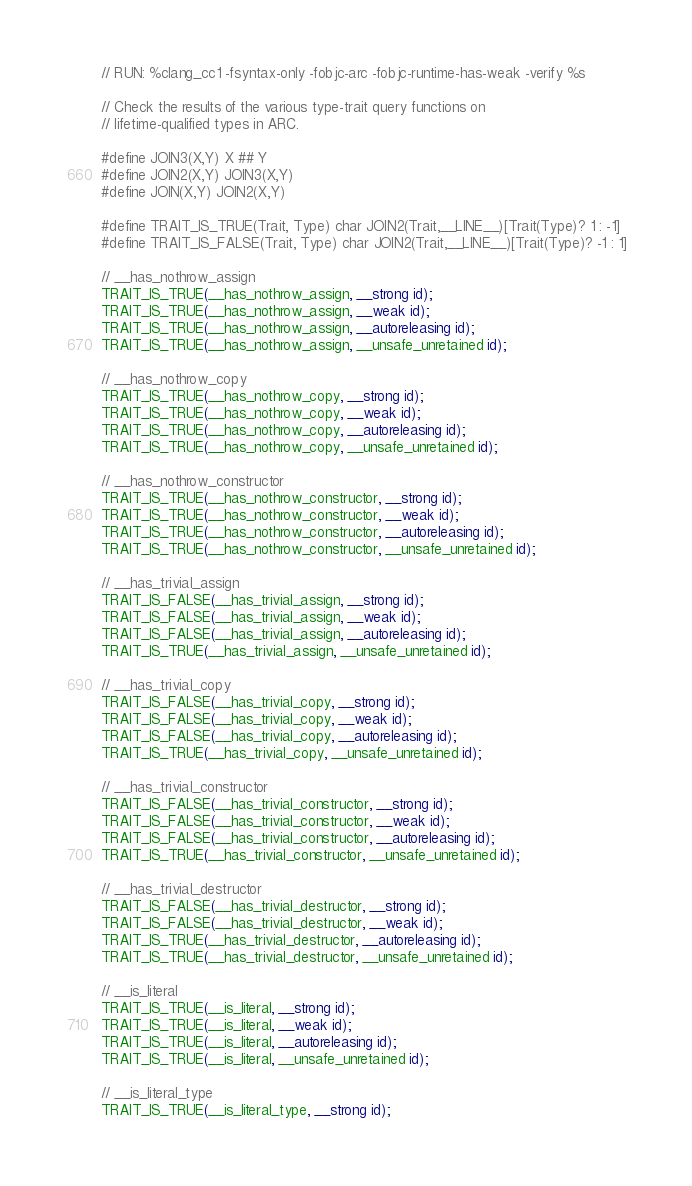<code> <loc_0><loc_0><loc_500><loc_500><_ObjectiveC_>// RUN: %clang_cc1 -fsyntax-only -fobjc-arc -fobjc-runtime-has-weak -verify %s

// Check the results of the various type-trait query functions on
// lifetime-qualified types in ARC.

#define JOIN3(X,Y) X ## Y
#define JOIN2(X,Y) JOIN3(X,Y)
#define JOIN(X,Y) JOIN2(X,Y)

#define TRAIT_IS_TRUE(Trait, Type) char JOIN2(Trait,__LINE__)[Trait(Type)? 1 : -1]
#define TRAIT_IS_FALSE(Trait, Type) char JOIN2(Trait,__LINE__)[Trait(Type)? -1 : 1]
  
// __has_nothrow_assign
TRAIT_IS_TRUE(__has_nothrow_assign, __strong id);
TRAIT_IS_TRUE(__has_nothrow_assign, __weak id);
TRAIT_IS_TRUE(__has_nothrow_assign, __autoreleasing id);
TRAIT_IS_TRUE(__has_nothrow_assign, __unsafe_unretained id);

// __has_nothrow_copy
TRAIT_IS_TRUE(__has_nothrow_copy, __strong id);
TRAIT_IS_TRUE(__has_nothrow_copy, __weak id);
TRAIT_IS_TRUE(__has_nothrow_copy, __autoreleasing id);
TRAIT_IS_TRUE(__has_nothrow_copy, __unsafe_unretained id);

// __has_nothrow_constructor
TRAIT_IS_TRUE(__has_nothrow_constructor, __strong id);
TRAIT_IS_TRUE(__has_nothrow_constructor, __weak id);
TRAIT_IS_TRUE(__has_nothrow_constructor, __autoreleasing id);
TRAIT_IS_TRUE(__has_nothrow_constructor, __unsafe_unretained id);

// __has_trivial_assign
TRAIT_IS_FALSE(__has_trivial_assign, __strong id);
TRAIT_IS_FALSE(__has_trivial_assign, __weak id);
TRAIT_IS_FALSE(__has_trivial_assign, __autoreleasing id);
TRAIT_IS_TRUE(__has_trivial_assign, __unsafe_unretained id);

// __has_trivial_copy
TRAIT_IS_FALSE(__has_trivial_copy, __strong id);
TRAIT_IS_FALSE(__has_trivial_copy, __weak id);
TRAIT_IS_FALSE(__has_trivial_copy, __autoreleasing id);
TRAIT_IS_TRUE(__has_trivial_copy, __unsafe_unretained id);

// __has_trivial_constructor
TRAIT_IS_FALSE(__has_trivial_constructor, __strong id);
TRAIT_IS_FALSE(__has_trivial_constructor, __weak id);
TRAIT_IS_FALSE(__has_trivial_constructor, __autoreleasing id);
TRAIT_IS_TRUE(__has_trivial_constructor, __unsafe_unretained id);

// __has_trivial_destructor
TRAIT_IS_FALSE(__has_trivial_destructor, __strong id);
TRAIT_IS_FALSE(__has_trivial_destructor, __weak id);
TRAIT_IS_TRUE(__has_trivial_destructor, __autoreleasing id);
TRAIT_IS_TRUE(__has_trivial_destructor, __unsafe_unretained id);

// __is_literal
TRAIT_IS_TRUE(__is_literal, __strong id);
TRAIT_IS_TRUE(__is_literal, __weak id);
TRAIT_IS_TRUE(__is_literal, __autoreleasing id);
TRAIT_IS_TRUE(__is_literal, __unsafe_unretained id);

// __is_literal_type
TRAIT_IS_TRUE(__is_literal_type, __strong id);</code> 